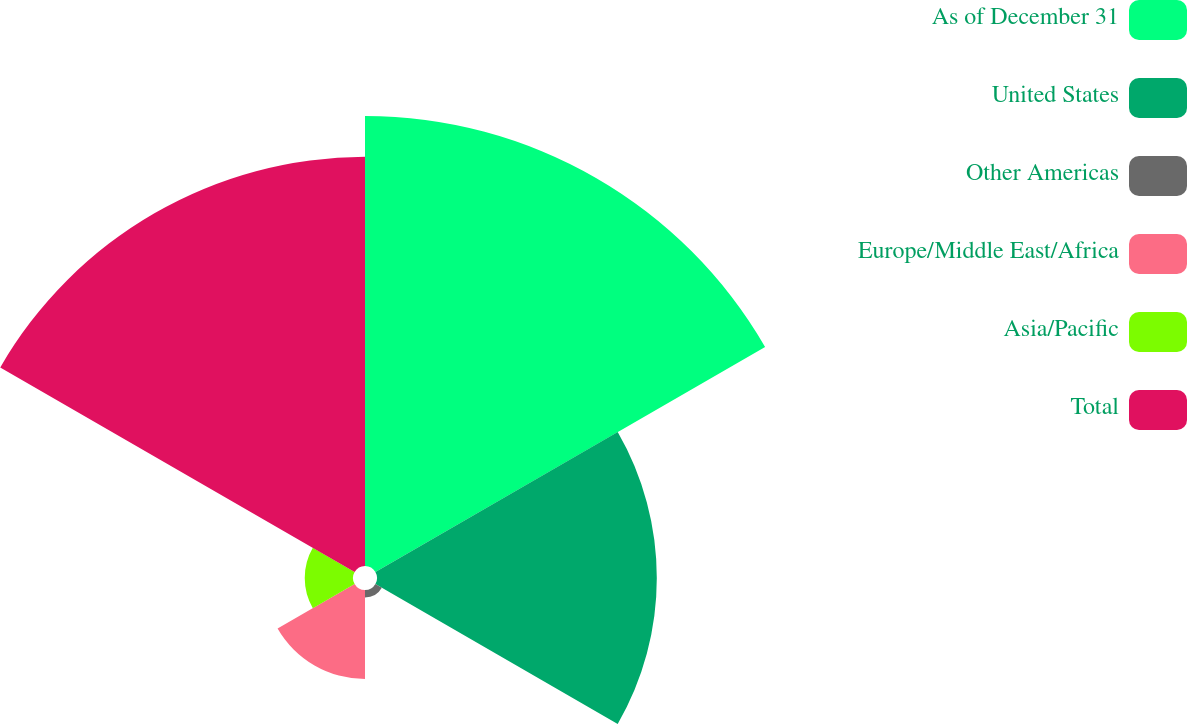Convert chart to OTSL. <chart><loc_0><loc_0><loc_500><loc_500><pie_chart><fcel>As of December 31<fcel>United States<fcel>Other Americas<fcel>Europe/Middle East/Africa<fcel>Asia/Pacific<fcel>Total<nl><fcel>35.06%<fcel>21.8%<fcel>0.58%<fcel>6.93%<fcel>3.76%<fcel>31.88%<nl></chart> 